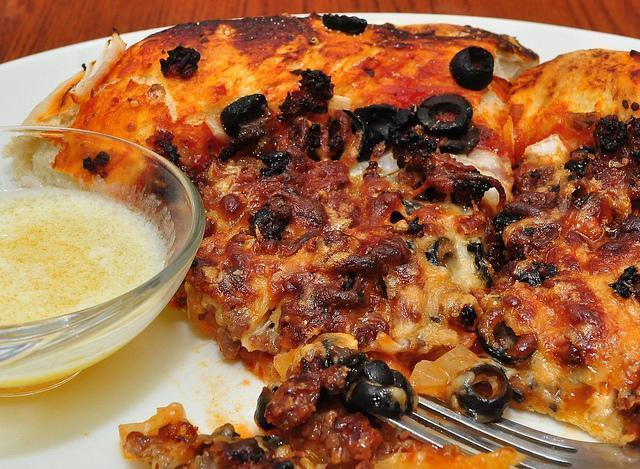How many giraffes are there?
Give a very brief answer. 0. 